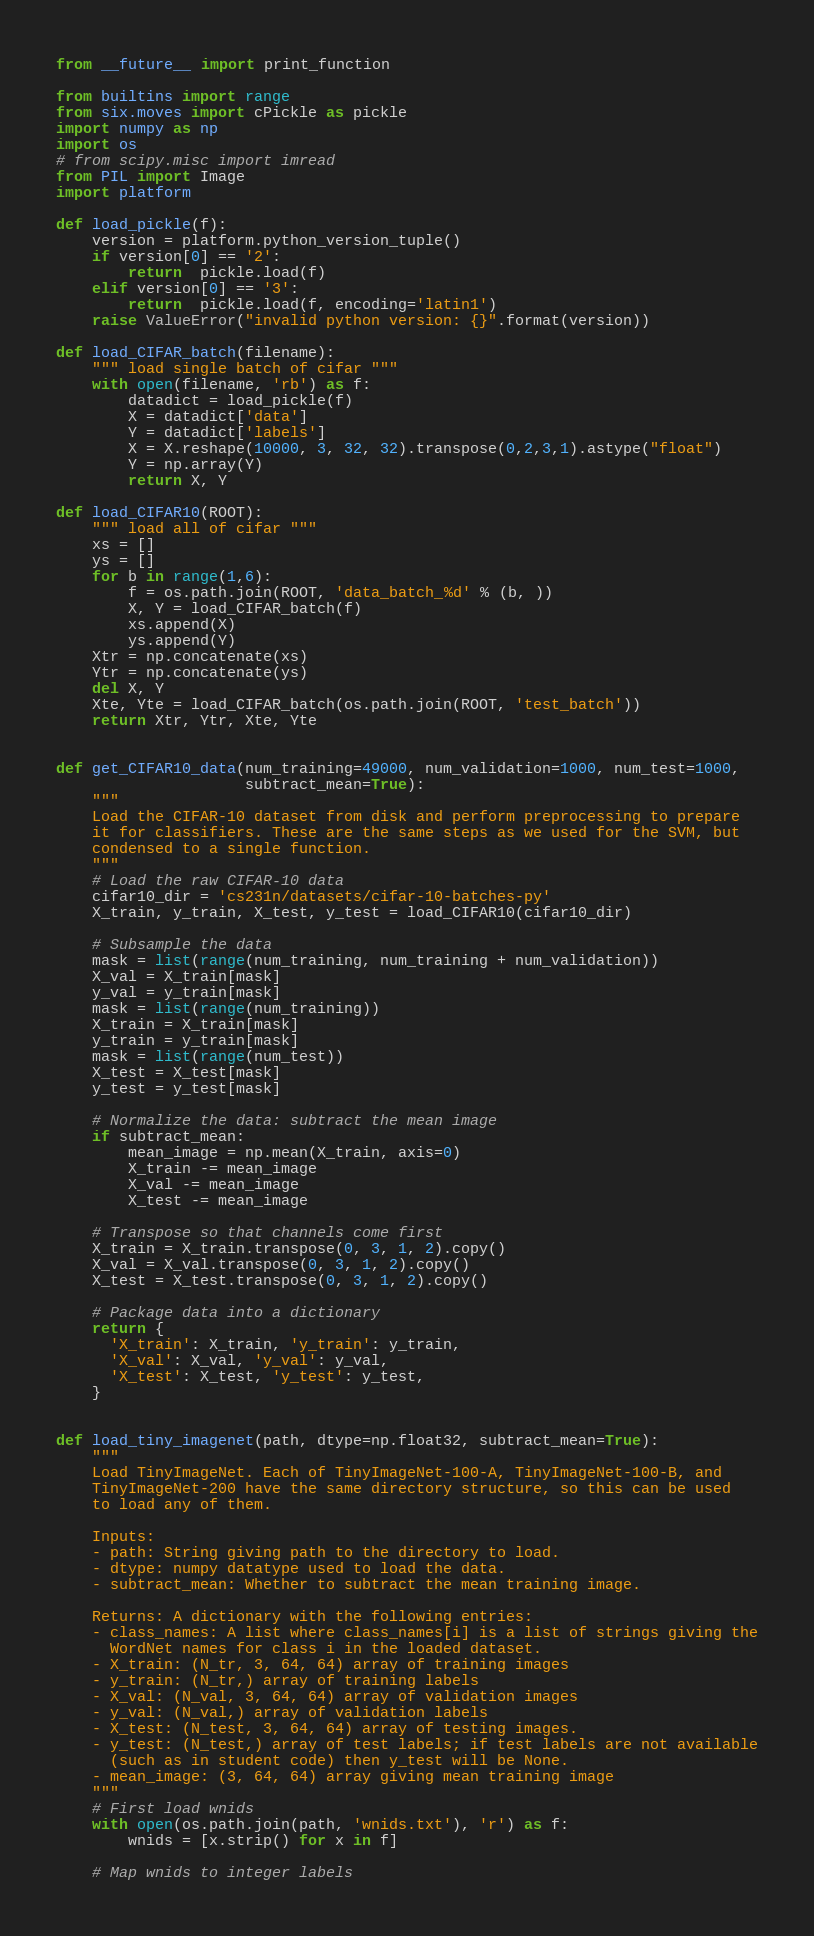<code> <loc_0><loc_0><loc_500><loc_500><_Python_>from __future__ import print_function

from builtins import range
from six.moves import cPickle as pickle
import numpy as np
import os
# from scipy.misc import imread
from PIL import Image
import platform

def load_pickle(f):
    version = platform.python_version_tuple()
    if version[0] == '2':
        return  pickle.load(f)
    elif version[0] == '3':
        return  pickle.load(f, encoding='latin1')
    raise ValueError("invalid python version: {}".format(version))

def load_CIFAR_batch(filename):
    """ load single batch of cifar """
    with open(filename, 'rb') as f:
        datadict = load_pickle(f)
        X = datadict['data']
        Y = datadict['labels']
        X = X.reshape(10000, 3, 32, 32).transpose(0,2,3,1).astype("float")
        Y = np.array(Y)
        return X, Y

def load_CIFAR10(ROOT):
    """ load all of cifar """
    xs = []
    ys = []
    for b in range(1,6):
        f = os.path.join(ROOT, 'data_batch_%d' % (b, ))
        X, Y = load_CIFAR_batch(f)
        xs.append(X)
        ys.append(Y)
    Xtr = np.concatenate(xs)
    Ytr = np.concatenate(ys)
    del X, Y
    Xte, Yte = load_CIFAR_batch(os.path.join(ROOT, 'test_batch'))
    return Xtr, Ytr, Xte, Yte


def get_CIFAR10_data(num_training=49000, num_validation=1000, num_test=1000,
                     subtract_mean=True):
    """
    Load the CIFAR-10 dataset from disk and perform preprocessing to prepare
    it for classifiers. These are the same steps as we used for the SVM, but
    condensed to a single function.
    """
    # Load the raw CIFAR-10 data
    cifar10_dir = 'cs231n/datasets/cifar-10-batches-py'
    X_train, y_train, X_test, y_test = load_CIFAR10(cifar10_dir)

    # Subsample the data
    mask = list(range(num_training, num_training + num_validation))
    X_val = X_train[mask]
    y_val = y_train[mask]
    mask = list(range(num_training))
    X_train = X_train[mask]
    y_train = y_train[mask]
    mask = list(range(num_test))
    X_test = X_test[mask]
    y_test = y_test[mask]

    # Normalize the data: subtract the mean image
    if subtract_mean:
        mean_image = np.mean(X_train, axis=0)
        X_train -= mean_image
        X_val -= mean_image
        X_test -= mean_image

    # Transpose so that channels come first
    X_train = X_train.transpose(0, 3, 1, 2).copy()
    X_val = X_val.transpose(0, 3, 1, 2).copy()
    X_test = X_test.transpose(0, 3, 1, 2).copy()

    # Package data into a dictionary
    return {
      'X_train': X_train, 'y_train': y_train,
      'X_val': X_val, 'y_val': y_val,
      'X_test': X_test, 'y_test': y_test,
    }


def load_tiny_imagenet(path, dtype=np.float32, subtract_mean=True):
    """
    Load TinyImageNet. Each of TinyImageNet-100-A, TinyImageNet-100-B, and
    TinyImageNet-200 have the same directory structure, so this can be used
    to load any of them.

    Inputs:
    - path: String giving path to the directory to load.
    - dtype: numpy datatype used to load the data.
    - subtract_mean: Whether to subtract the mean training image.

    Returns: A dictionary with the following entries:
    - class_names: A list where class_names[i] is a list of strings giving the
      WordNet names for class i in the loaded dataset.
    - X_train: (N_tr, 3, 64, 64) array of training images
    - y_train: (N_tr,) array of training labels
    - X_val: (N_val, 3, 64, 64) array of validation images
    - y_val: (N_val,) array of validation labels
    - X_test: (N_test, 3, 64, 64) array of testing images.
    - y_test: (N_test,) array of test labels; if test labels are not available
      (such as in student code) then y_test will be None.
    - mean_image: (3, 64, 64) array giving mean training image
    """
    # First load wnids
    with open(os.path.join(path, 'wnids.txt'), 'r') as f:
        wnids = [x.strip() for x in f]

    # Map wnids to integer labels</code> 